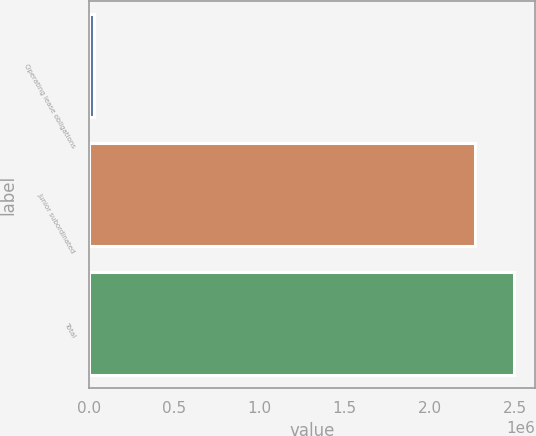Convert chart. <chart><loc_0><loc_0><loc_500><loc_500><bar_chart><fcel>Operating lease obligations<fcel>Junior subordinated<fcel>Total<nl><fcel>24284<fcel>2.26562e+06<fcel>2.49219e+06<nl></chart> 